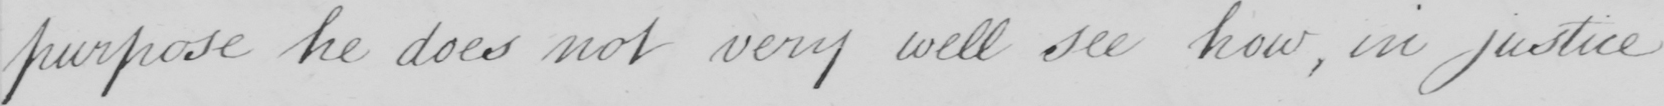What text is written in this handwritten line? purpose he does not very well see how , in justice 